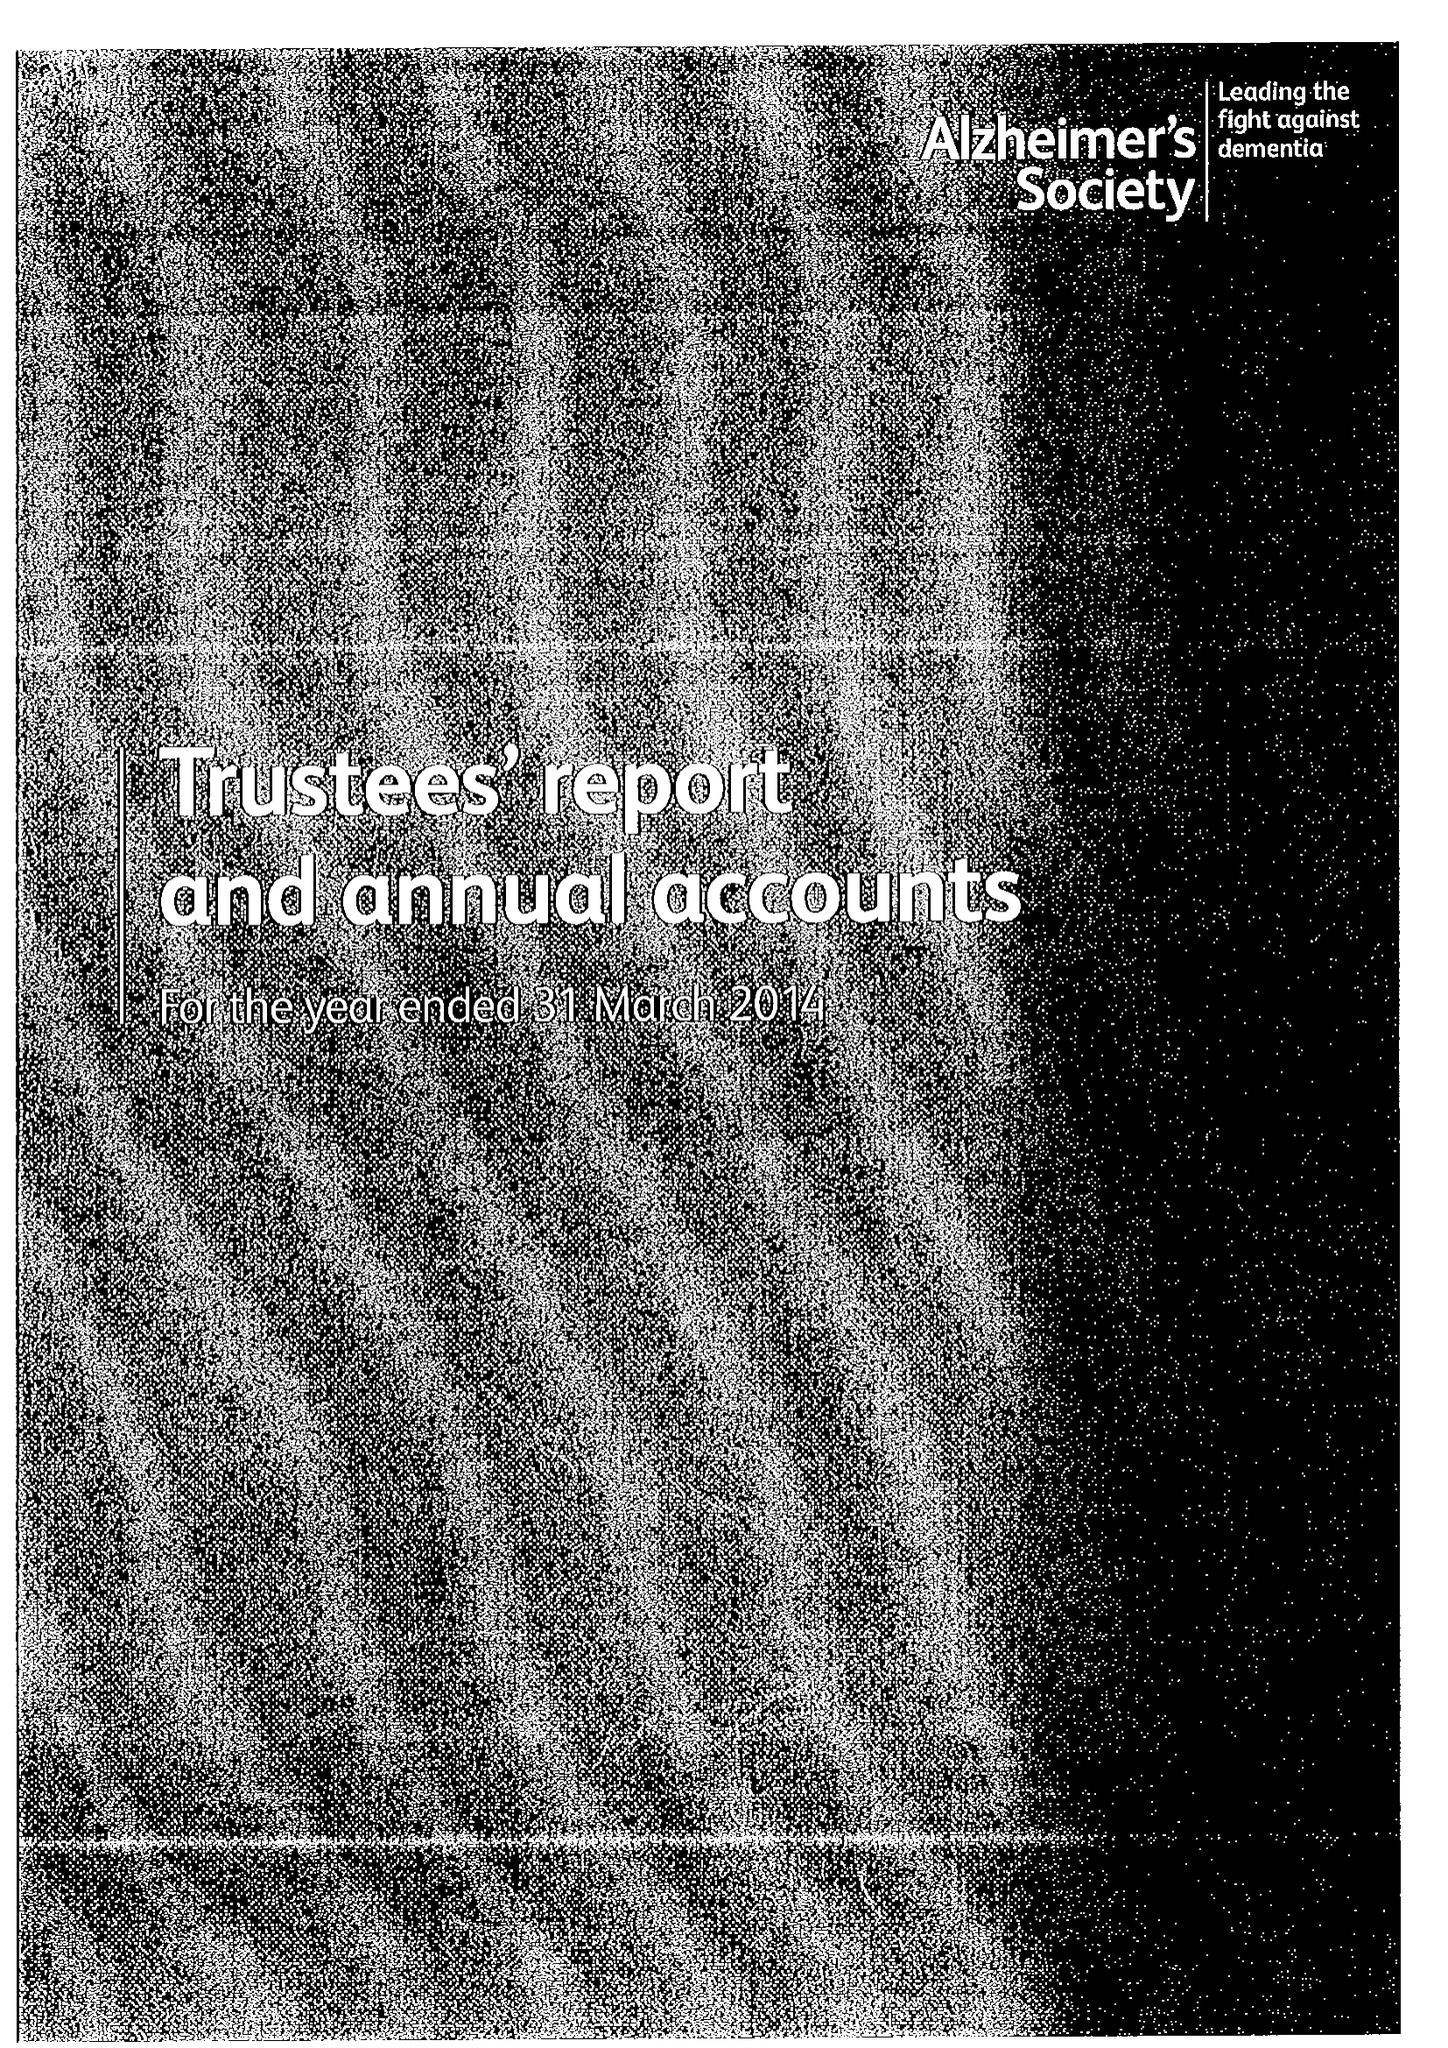What is the value for the address__postcode?
Answer the question using a single word or phrase. EC3N 2AE 